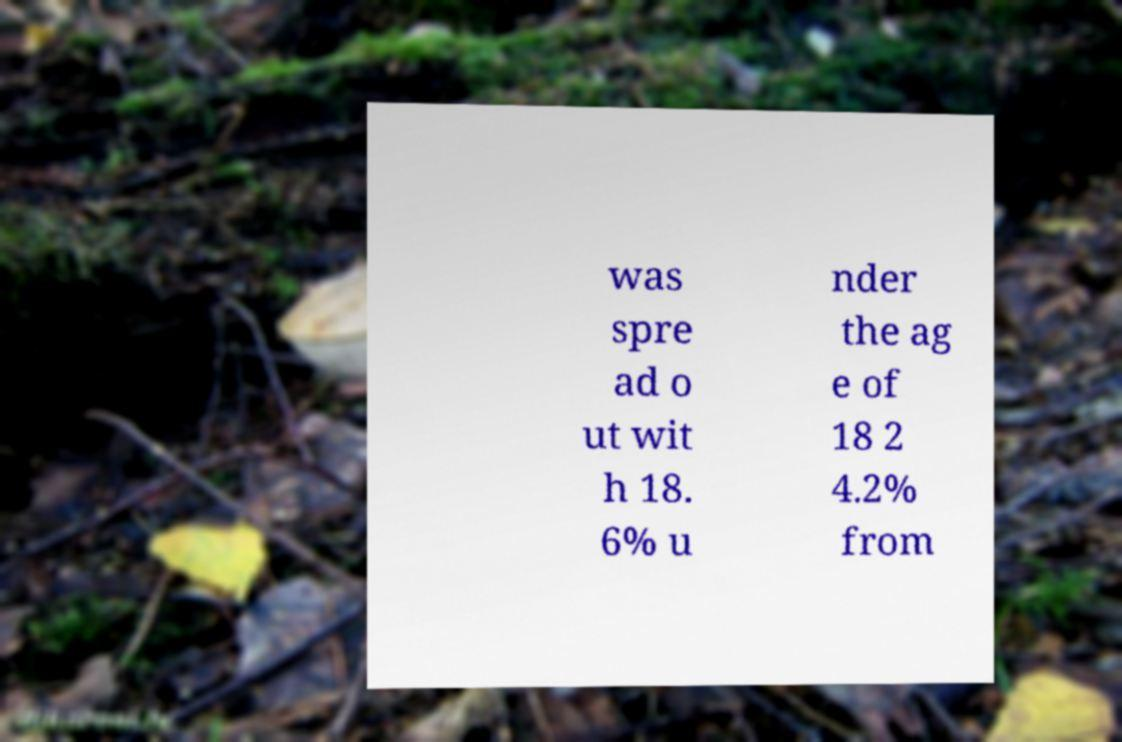Could you assist in decoding the text presented in this image and type it out clearly? was spre ad o ut wit h 18. 6% u nder the ag e of 18 2 4.2% from 